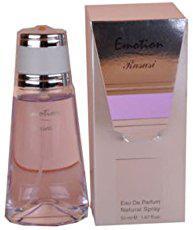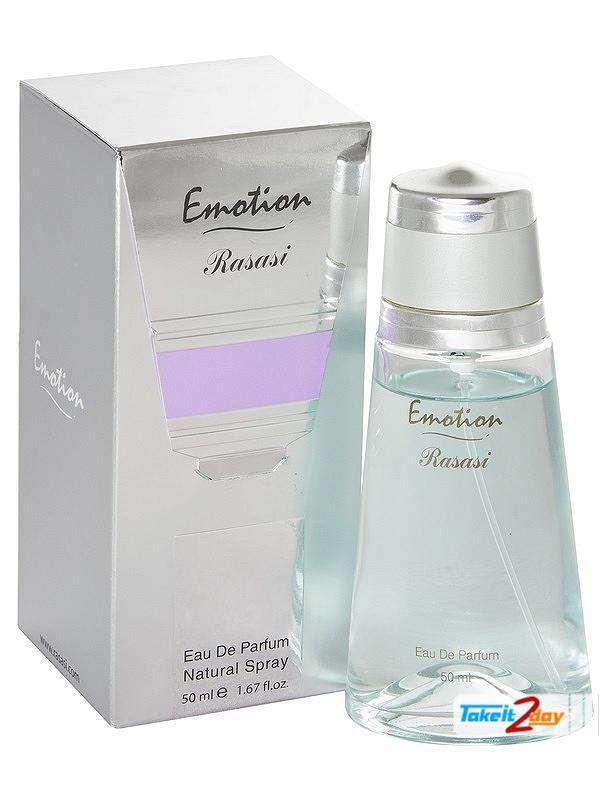The first image is the image on the left, the second image is the image on the right. Examine the images to the left and right. Is the description "There is a bottle of perfume without a box next to it." accurate? Answer yes or no. No. 